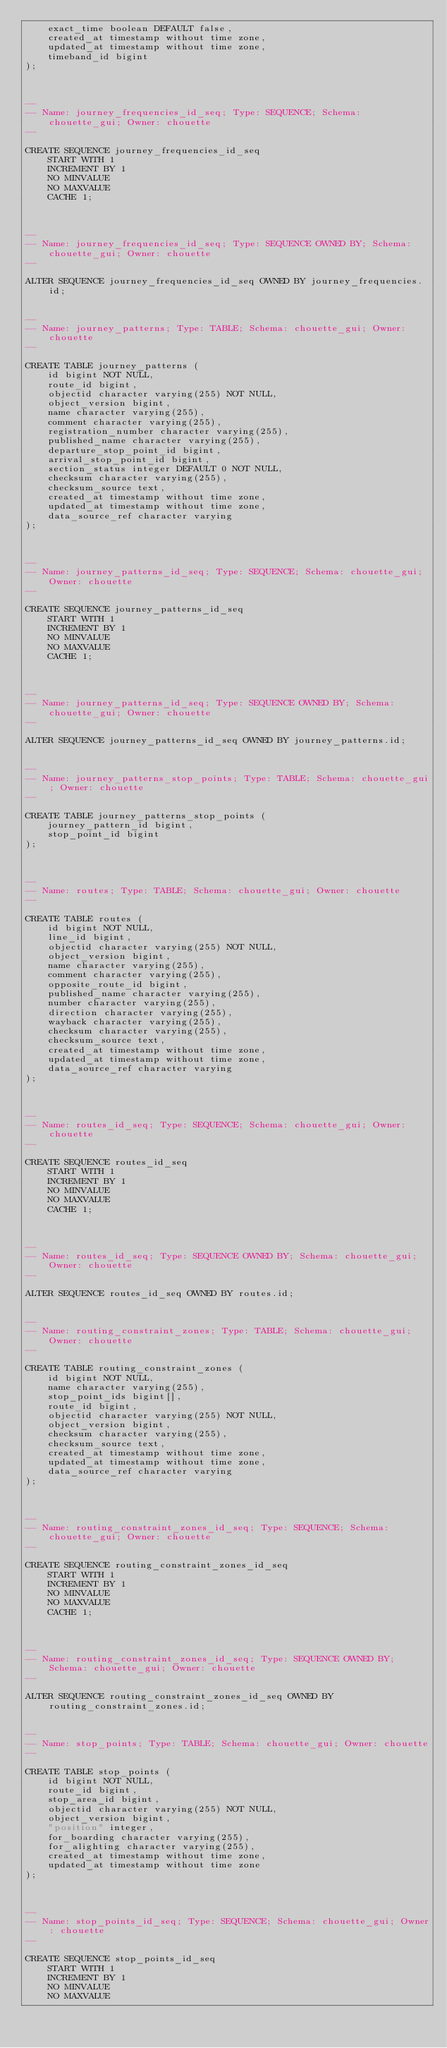<code> <loc_0><loc_0><loc_500><loc_500><_SQL_>    exact_time boolean DEFAULT false,
    created_at timestamp without time zone,
    updated_at timestamp without time zone,
    timeband_id bigint
);



--
-- Name: journey_frequencies_id_seq; Type: SEQUENCE; Schema: chouette_gui; Owner: chouette
--

CREATE SEQUENCE journey_frequencies_id_seq
    START WITH 1
    INCREMENT BY 1
    NO MINVALUE
    NO MAXVALUE
    CACHE 1;



--
-- Name: journey_frequencies_id_seq; Type: SEQUENCE OWNED BY; Schema: chouette_gui; Owner: chouette
--

ALTER SEQUENCE journey_frequencies_id_seq OWNED BY journey_frequencies.id;


--
-- Name: journey_patterns; Type: TABLE; Schema: chouette_gui; Owner: chouette
--

CREATE TABLE journey_patterns (
    id bigint NOT NULL,
    route_id bigint,
    objectid character varying(255) NOT NULL,
    object_version bigint,
    name character varying(255),
    comment character varying(255),
    registration_number character varying(255),
    published_name character varying(255),
    departure_stop_point_id bigint,
    arrival_stop_point_id bigint,
    section_status integer DEFAULT 0 NOT NULL,
    checksum character varying(255),
    checksum_source text,
    created_at timestamp without time zone,
    updated_at timestamp without time zone,
    data_source_ref character varying
);



--
-- Name: journey_patterns_id_seq; Type: SEQUENCE; Schema: chouette_gui; Owner: chouette
--

CREATE SEQUENCE journey_patterns_id_seq
    START WITH 1
    INCREMENT BY 1
    NO MINVALUE
    NO MAXVALUE
    CACHE 1;



--
-- Name: journey_patterns_id_seq; Type: SEQUENCE OWNED BY; Schema: chouette_gui; Owner: chouette
--

ALTER SEQUENCE journey_patterns_id_seq OWNED BY journey_patterns.id;


--
-- Name: journey_patterns_stop_points; Type: TABLE; Schema: chouette_gui; Owner: chouette
--

CREATE TABLE journey_patterns_stop_points (
    journey_pattern_id bigint,
    stop_point_id bigint
);



--
-- Name: routes; Type: TABLE; Schema: chouette_gui; Owner: chouette
--

CREATE TABLE routes (
    id bigint NOT NULL,
    line_id bigint,
    objectid character varying(255) NOT NULL,
    object_version bigint,
    name character varying(255),
    comment character varying(255),
    opposite_route_id bigint,
    published_name character varying(255),
    number character varying(255),
    direction character varying(255),
    wayback character varying(255),
    checksum character varying(255),
    checksum_source text,
    created_at timestamp without time zone,
    updated_at timestamp without time zone,
    data_source_ref character varying
);



--
-- Name: routes_id_seq; Type: SEQUENCE; Schema: chouette_gui; Owner: chouette
--

CREATE SEQUENCE routes_id_seq
    START WITH 1
    INCREMENT BY 1
    NO MINVALUE
    NO MAXVALUE
    CACHE 1;



--
-- Name: routes_id_seq; Type: SEQUENCE OWNED BY; Schema: chouette_gui; Owner: chouette
--

ALTER SEQUENCE routes_id_seq OWNED BY routes.id;


--
-- Name: routing_constraint_zones; Type: TABLE; Schema: chouette_gui; Owner: chouette
--

CREATE TABLE routing_constraint_zones (
    id bigint NOT NULL,
    name character varying(255),
    stop_point_ids bigint[],
    route_id bigint,
    objectid character varying(255) NOT NULL,
    object_version bigint,
    checksum character varying(255),
    checksum_source text,
    created_at timestamp without time zone,
    updated_at timestamp without time zone,
    data_source_ref character varying
);



--
-- Name: routing_constraint_zones_id_seq; Type: SEQUENCE; Schema: chouette_gui; Owner: chouette
--

CREATE SEQUENCE routing_constraint_zones_id_seq
    START WITH 1
    INCREMENT BY 1
    NO MINVALUE
    NO MAXVALUE
    CACHE 1;



--
-- Name: routing_constraint_zones_id_seq; Type: SEQUENCE OWNED BY; Schema: chouette_gui; Owner: chouette
--

ALTER SEQUENCE routing_constraint_zones_id_seq OWNED BY routing_constraint_zones.id;


--
-- Name: stop_points; Type: TABLE; Schema: chouette_gui; Owner: chouette
--

CREATE TABLE stop_points (
    id bigint NOT NULL,
    route_id bigint,
    stop_area_id bigint,
    objectid character varying(255) NOT NULL,
    object_version bigint,
    "position" integer,
    for_boarding character varying(255),
    for_alighting character varying(255),
    created_at timestamp without time zone,
    updated_at timestamp without time zone
);



--
-- Name: stop_points_id_seq; Type: SEQUENCE; Schema: chouette_gui; Owner: chouette
--

CREATE SEQUENCE stop_points_id_seq
    START WITH 1
    INCREMENT BY 1
    NO MINVALUE
    NO MAXVALUE</code> 